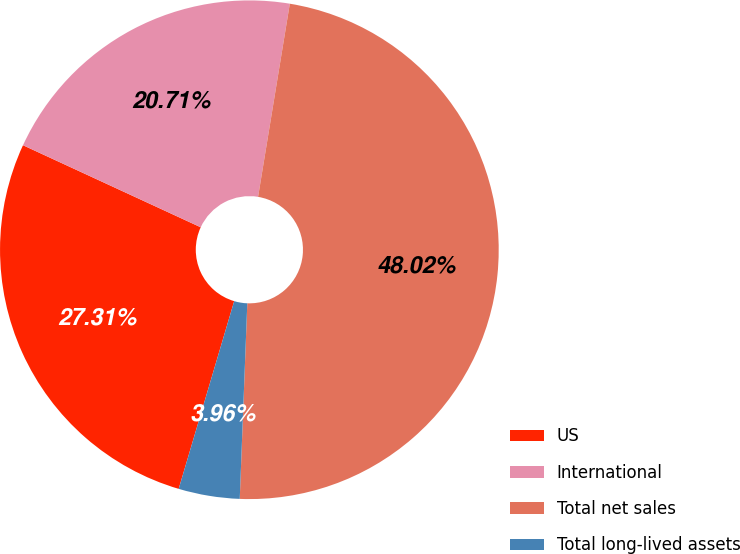<chart> <loc_0><loc_0><loc_500><loc_500><pie_chart><fcel>US<fcel>International<fcel>Total net sales<fcel>Total long-lived assets<nl><fcel>27.31%<fcel>20.71%<fcel>48.02%<fcel>3.96%<nl></chart> 